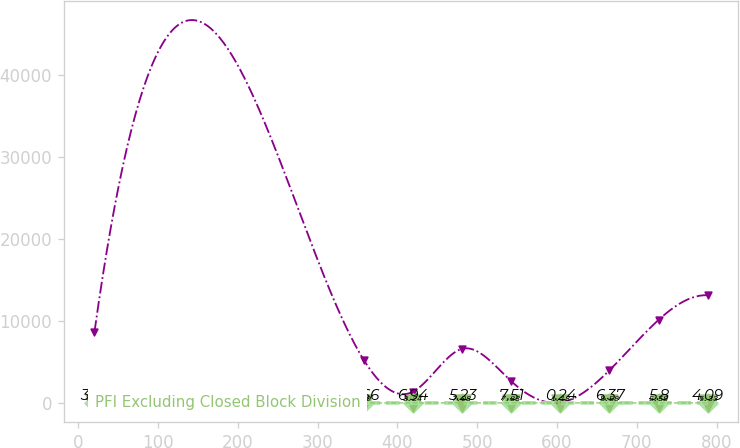Convert chart. <chart><loc_0><loc_0><loc_500><loc_500><line_chart><ecel><fcel>Unnamed: 1<fcel>Closed Block Division<fcel>PFI Excluding Closed Block Division<nl><fcel>20.34<fcel>8649.17<fcel>4.83<fcel>3.52<nl><fcel>357.52<fcel>5273.92<fcel>0<fcel>4.66<nl><fcel>419.13<fcel>1353.49<fcel>3.24<fcel>6.94<nl><fcel>480.74<fcel>6580.73<fcel>7.08<fcel>5.23<nl><fcel>542.35<fcel>2660.3<fcel>7.83<fcel>7.51<nl><fcel>603.96<fcel>46.68<fcel>1.18<fcel>0.24<nl><fcel>665.57<fcel>3967.11<fcel>8.58<fcel>6.37<nl><fcel>727.18<fcel>10112.2<fcel>5.58<fcel>5.8<nl><fcel>788.79<fcel>13114.8<fcel>6.33<fcel>4.09<nl></chart> 